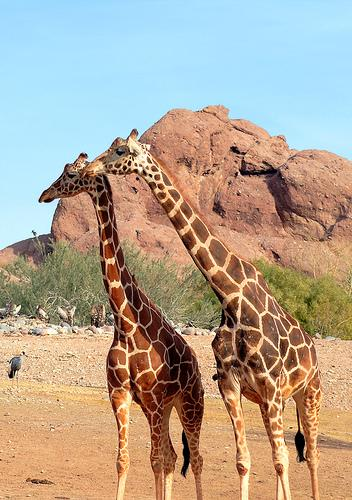Elucidate the state of the soil in the image. The soil appears dry and sandy, with some sparse vegetation and rocks scattered around. Count the number of visible giraffe legs in the image. There are eight visible legs, as two giraffes are present in the image. Discuss any notable information about the giraffe's neck. The giraffes' necks are long and slender, covered with a pattern of brown spots against a lighter background, which is typical for giraffes. Point out the features of the tail in the image. The tails of the giraffes are thin and long, ending in a tuft of dark hair. Analyze the exposure of the adult giraffe's ears in the image. The ears of both giraffes are clearly visible, upright, and pointed, positioned on top of their heads. Relate the objects present in the image that might be interacting with one another. The two giraffes are standing close to each other, possibly interacting or moving together, with their bodies oriented in the same direction. What is the primary object seen in the image? The primary objects in the image are two tall giraffes standing close to each other. Illustrate the background of the image. The background features a rocky hill with sparse vegetation under a clear blue sky. Identify any secondary animals within the image. There is a bird visible on the ground near the giraffes. Could you describe the nature of the image in terms of sentiment? The image conveys a peaceful and natural setting, showcasing wildlife in a serene environment. 